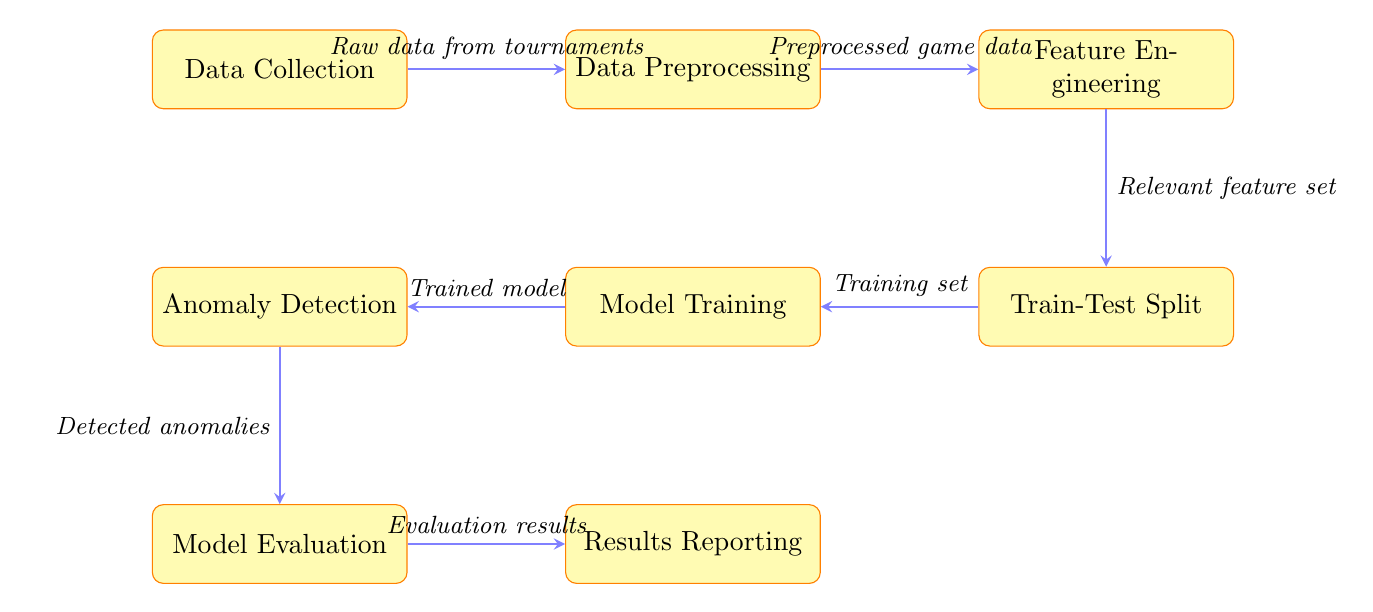What is the first node in the diagram? The first node in the diagram is labeled "Data Collection," which indicates the starting point where data is gathered.
Answer: Data Collection How many nodes are there in total? By counting all the distinct process nodes in the diagram, we find there are eight nodes: Data Collection, Data Preprocessing, Feature Engineering, Train-Test Split, Model Training, Anomaly Detection, Model Evaluation, and Results Reporting.
Answer: Eight What is the output of the "Anomaly Detection" node? The output of the "Anomaly Detection" node is "Detected anomalies," which represents the result of the anomaly detection process based on the trained model.
Answer: Detected anomalies What does the "Feature Engineering" node produce? The output from the "Feature Engineering" node is labeled "Relevant feature set," which indicates that this node produces a set of features that are relevant for the training of the model.
Answer: Relevant feature set Which node receives the output from the "Model Evaluation" node? The "Results Reporting" node receives the output from the "Model Evaluation" node, indicating that the results of the evaluation are reported next.
Answer: Results Reporting What type of data is fed into the "Data Preprocessing" node? The input fed into the "Data Preprocessing" node is labeled "Raw data from tournaments," indicating that it is the initial unprocessed data collected from chess tournaments.
Answer: Raw data from tournaments Which two nodes are connected directly by an arrow with the label "Training set"? The "Train-Test Split" and "Model Training" nodes are connected directly by an arrow labeled "Training set," showing the flow from splitting the data to model training.
Answer: Train-Test Split and Model Training What step follows immediately after "Model Training"? The step that follows immediately after "Model Training" is "Anomaly Detection," where the trained model is then used to detect anomalies in the game strategies.
Answer: Anomaly Detection 